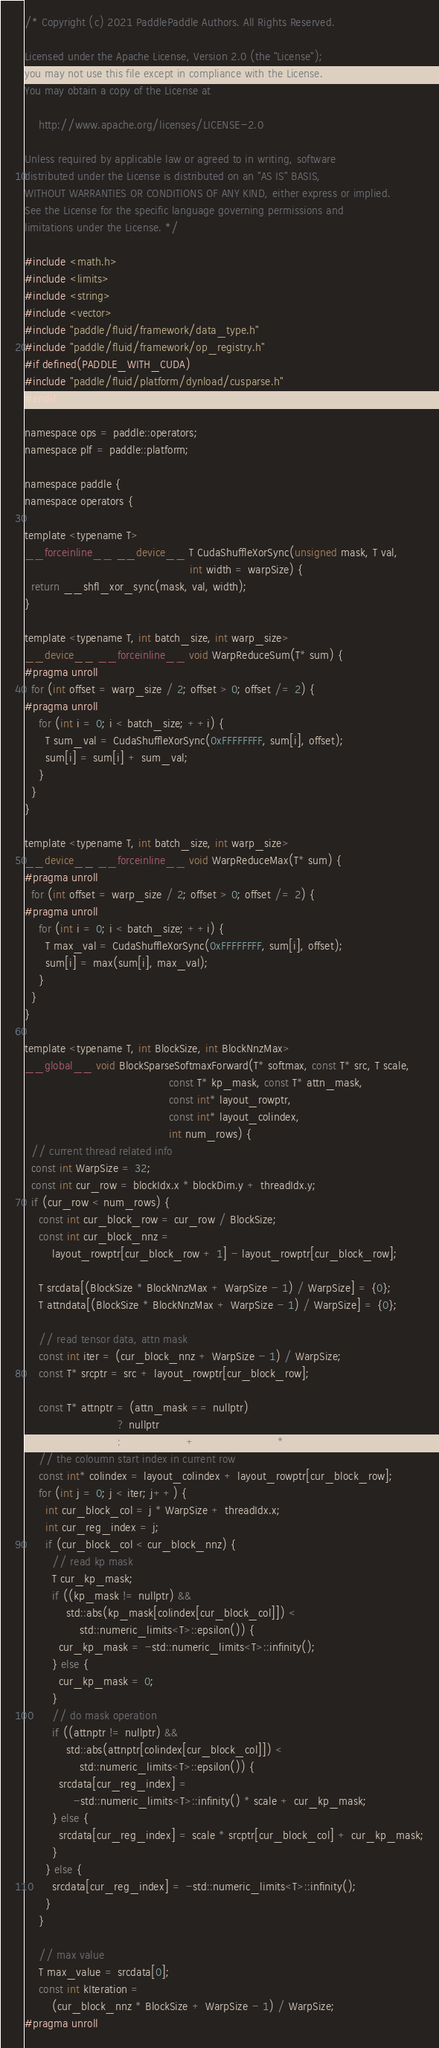<code> <loc_0><loc_0><loc_500><loc_500><_Cuda_>/* Copyright (c) 2021 PaddlePaddle Authors. All Rights Reserved.

Licensed under the Apache License, Version 2.0 (the "License");
you may not use this file except in compliance with the License.
You may obtain a copy of the License at

    http://www.apache.org/licenses/LICENSE-2.0

Unless required by applicable law or agreed to in writing, software
distributed under the License is distributed on an "AS IS" BASIS,
WITHOUT WARRANTIES OR CONDITIONS OF ANY KIND, either express or implied.
See the License for the specific language governing permissions and
limitations under the License. */

#include <math.h>
#include <limits>
#include <string>
#include <vector>
#include "paddle/fluid/framework/data_type.h"
#include "paddle/fluid/framework/op_registry.h"
#if defined(PADDLE_WITH_CUDA)
#include "paddle/fluid/platform/dynload/cusparse.h"
#endif

namespace ops = paddle::operators;
namespace plf = paddle::platform;

namespace paddle {
namespace operators {

template <typename T>
__forceinline__ __device__ T CudaShuffleXorSync(unsigned mask, T val,
                                                int width = warpSize) {
  return __shfl_xor_sync(mask, val, width);
}

template <typename T, int batch_size, int warp_size>
__device__ __forceinline__ void WarpReduceSum(T* sum) {
#pragma unroll
  for (int offset = warp_size / 2; offset > 0; offset /= 2) {
#pragma unroll
    for (int i = 0; i < batch_size; ++i) {
      T sum_val = CudaShuffleXorSync(0xFFFFFFFF, sum[i], offset);
      sum[i] = sum[i] + sum_val;
    }
  }
}

template <typename T, int batch_size, int warp_size>
__device__ __forceinline__ void WarpReduceMax(T* sum) {
#pragma unroll
  for (int offset = warp_size / 2; offset > 0; offset /= 2) {
#pragma unroll
    for (int i = 0; i < batch_size; ++i) {
      T max_val = CudaShuffleXorSync(0xFFFFFFFF, sum[i], offset);
      sum[i] = max(sum[i], max_val);
    }
  }
}

template <typename T, int BlockSize, int BlockNnzMax>
__global__ void BlockSparseSoftmaxForward(T* softmax, const T* src, T scale,
                                          const T* kp_mask, const T* attn_mask,
                                          const int* layout_rowptr,
                                          const int* layout_colindex,
                                          int num_rows) {
  // current thread related info
  const int WarpSize = 32;
  const int cur_row = blockIdx.x * blockDim.y + threadIdx.y;
  if (cur_row < num_rows) {
    const int cur_block_row = cur_row / BlockSize;
    const int cur_block_nnz =
        layout_rowptr[cur_block_row + 1] - layout_rowptr[cur_block_row];

    T srcdata[(BlockSize * BlockNnzMax + WarpSize - 1) / WarpSize] = {0};
    T attndata[(BlockSize * BlockNnzMax + WarpSize - 1) / WarpSize] = {0};

    // read tensor data, attn mask
    const int iter = (cur_block_nnz + WarpSize - 1) / WarpSize;
    const T* srcptr = src + layout_rowptr[cur_block_row];

    const T* attnptr = (attn_mask == nullptr)
                           ? nullptr
                           : (attn_mask + cur_block_row * num_rows);
    // the coloumn start index in current row
    const int* colindex = layout_colindex + layout_rowptr[cur_block_row];
    for (int j = 0; j < iter; j++) {
      int cur_block_col = j * WarpSize + threadIdx.x;
      int cur_reg_index = j;
      if (cur_block_col < cur_block_nnz) {
        // read kp mask
        T cur_kp_mask;
        if ((kp_mask != nullptr) &&
            std::abs(kp_mask[colindex[cur_block_col]]) <
                std::numeric_limits<T>::epsilon()) {
          cur_kp_mask = -std::numeric_limits<T>::infinity();
        } else {
          cur_kp_mask = 0;
        }
        // do mask operation
        if ((attnptr != nullptr) &&
            std::abs(attnptr[colindex[cur_block_col]]) <
                std::numeric_limits<T>::epsilon()) {
          srcdata[cur_reg_index] =
              -std::numeric_limits<T>::infinity() * scale + cur_kp_mask;
        } else {
          srcdata[cur_reg_index] = scale * srcptr[cur_block_col] + cur_kp_mask;
        }
      } else {
        srcdata[cur_reg_index] = -std::numeric_limits<T>::infinity();
      }
    }

    // max value
    T max_value = srcdata[0];
    const int kIteration =
        (cur_block_nnz * BlockSize + WarpSize - 1) / WarpSize;
#pragma unroll</code> 